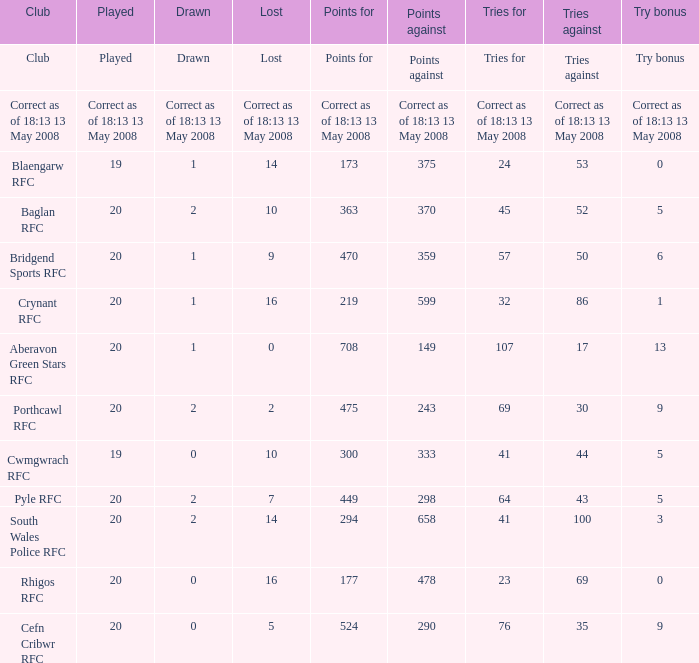What is the points when the try bonus is 1? 219.0. 